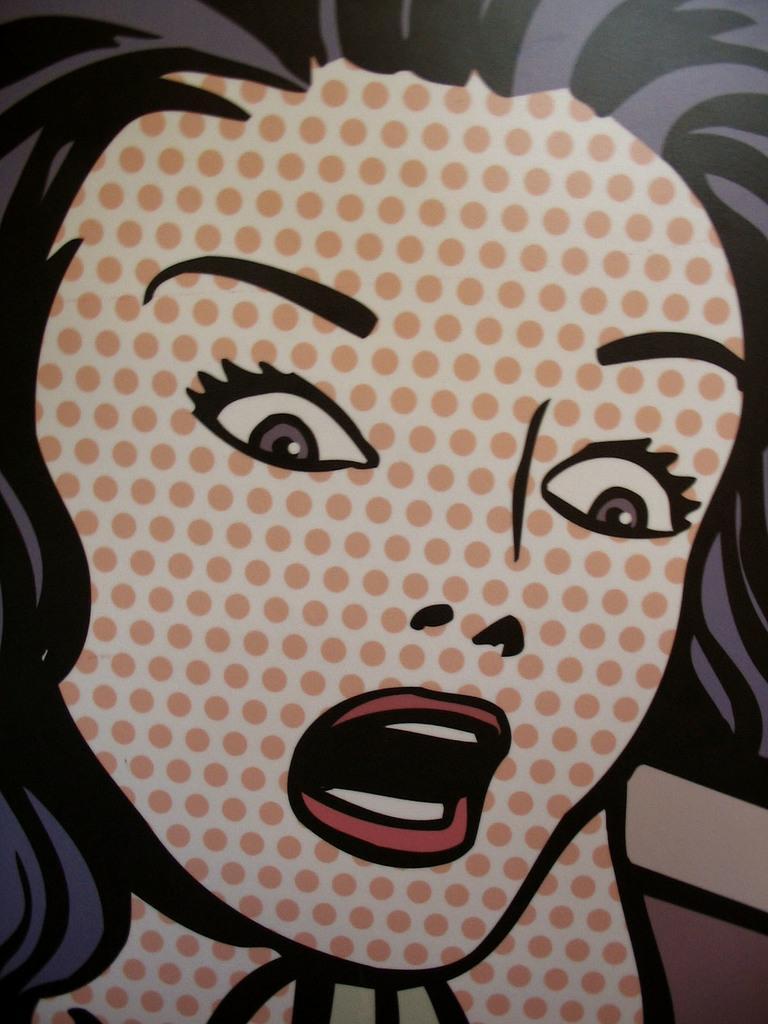Can you describe this image briefly? In this picture we can see a poster of a woman. On the top we can see her hair. 